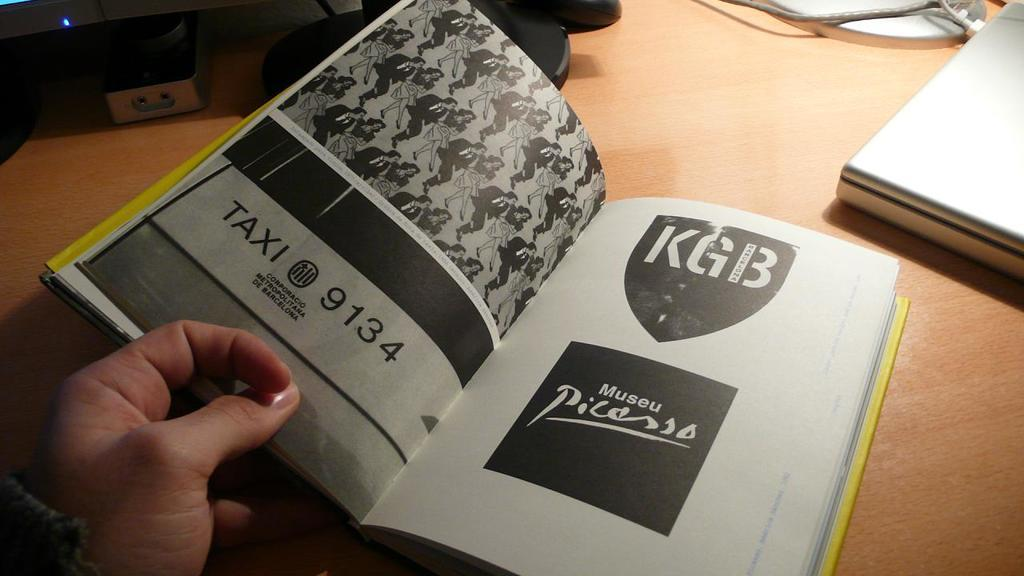<image>
Summarize the visual content of the image. a book with a page open that says 'kgb museu picasso' 